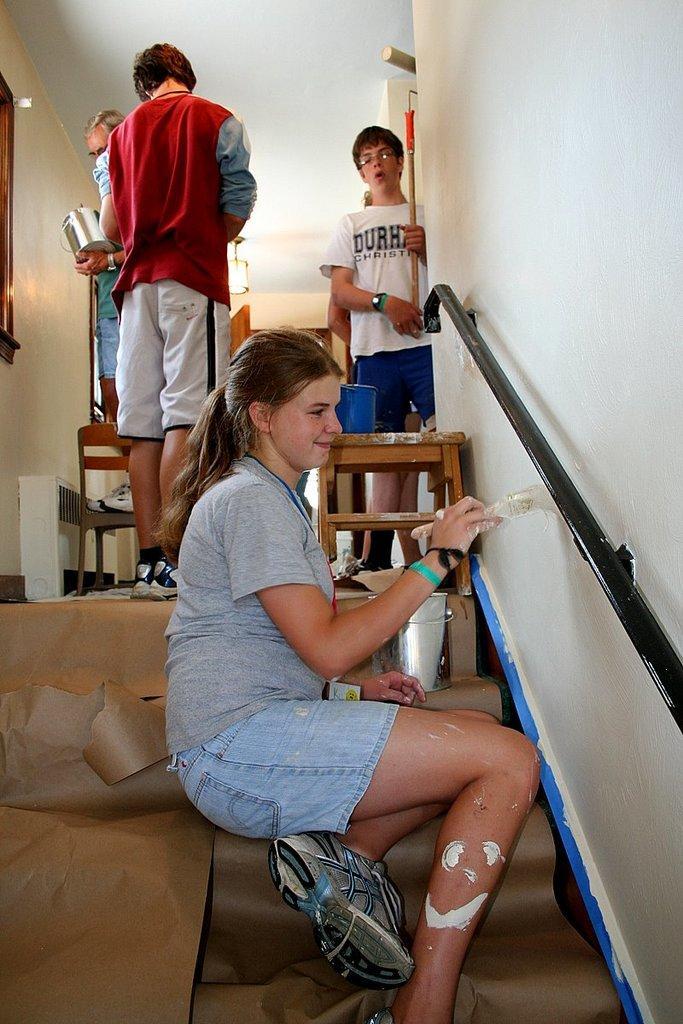Could you give a brief overview of what you see in this image? In this image we can see people standing and a woman is sitting on the stairs by holding a paint brush in her hands. In addition to this we can see air cooler, seating stools, container, railings and polythene cover on the stairs. 